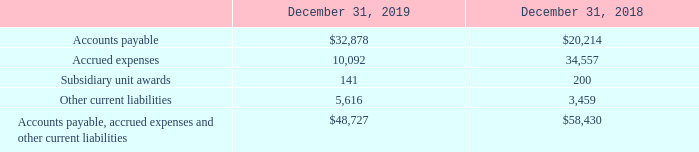Note 12. Liabilities
The components of accounts payable, accrued expenses and other current liabilities are as follows (in thousands):
What were the accounts payable in 2019?
Answer scale should be: thousand. 32,878. What were the subsidiary unit awards in 2019?
Answer scale should be: thousand. 141. What were the accrued expenses in 2018?
Answer scale should be: thousand. 34,557. What was the change in the Subsidiary unit awards between 2018 and 2019?
Answer scale should be: thousand. 141-200
Answer: -59. How many components in 2018 exceeded $10,000 thousand? Accounts payable##Accrued expenses
Answer: 2. What was the percentage change between accounts payable in 2018 and 2019?
Answer scale should be: percent. (32,878-20,214)/20,214
Answer: 62.65. 